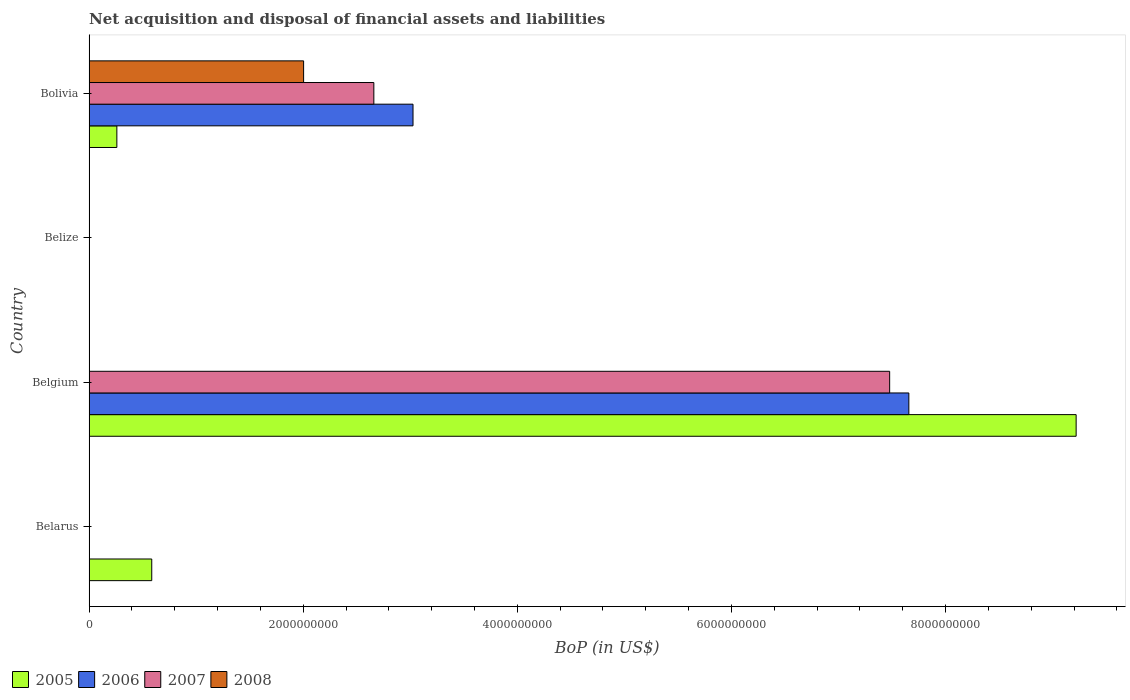How many different coloured bars are there?
Provide a succinct answer. 4. Are the number of bars per tick equal to the number of legend labels?
Ensure brevity in your answer.  No. Are the number of bars on each tick of the Y-axis equal?
Provide a short and direct response. No. What is the label of the 3rd group of bars from the top?
Keep it short and to the point. Belgium. Across all countries, what is the maximum Balance of Payments in 2005?
Offer a terse response. 9.22e+09. Across all countries, what is the minimum Balance of Payments in 2005?
Your response must be concise. 0. What is the total Balance of Payments in 2005 in the graph?
Offer a very short reply. 1.01e+1. What is the difference between the Balance of Payments in 2005 in Belarus and that in Bolivia?
Your answer should be very brief. 3.26e+08. What is the difference between the Balance of Payments in 2007 in Bolivia and the Balance of Payments in 2005 in Belize?
Offer a terse response. 2.66e+09. What is the average Balance of Payments in 2007 per country?
Offer a terse response. 2.53e+09. What is the difference between the Balance of Payments in 2005 and Balance of Payments in 2007 in Belgium?
Provide a succinct answer. 1.74e+09. What is the difference between the highest and the second highest Balance of Payments in 2005?
Your response must be concise. 8.63e+09. What is the difference between the highest and the lowest Balance of Payments in 2008?
Ensure brevity in your answer.  2.00e+09. Is the sum of the Balance of Payments in 2005 in Belarus and Belgium greater than the maximum Balance of Payments in 2007 across all countries?
Keep it short and to the point. Yes. Is it the case that in every country, the sum of the Balance of Payments in 2005 and Balance of Payments in 2008 is greater than the sum of Balance of Payments in 2006 and Balance of Payments in 2007?
Offer a terse response. No. Are the values on the major ticks of X-axis written in scientific E-notation?
Make the answer very short. No. Does the graph contain grids?
Your response must be concise. No. What is the title of the graph?
Offer a terse response. Net acquisition and disposal of financial assets and liabilities. What is the label or title of the X-axis?
Your response must be concise. BoP (in US$). What is the BoP (in US$) in 2005 in Belarus?
Provide a short and direct response. 5.85e+08. What is the BoP (in US$) of 2005 in Belgium?
Give a very brief answer. 9.22e+09. What is the BoP (in US$) in 2006 in Belgium?
Give a very brief answer. 7.66e+09. What is the BoP (in US$) of 2007 in Belgium?
Your answer should be compact. 7.48e+09. What is the BoP (in US$) of 2008 in Belgium?
Give a very brief answer. 0. What is the BoP (in US$) of 2005 in Belize?
Offer a terse response. 0. What is the BoP (in US$) of 2007 in Belize?
Your answer should be compact. 0. What is the BoP (in US$) of 2005 in Bolivia?
Offer a very short reply. 2.59e+08. What is the BoP (in US$) of 2006 in Bolivia?
Your response must be concise. 3.03e+09. What is the BoP (in US$) of 2007 in Bolivia?
Provide a succinct answer. 2.66e+09. What is the BoP (in US$) in 2008 in Bolivia?
Your answer should be compact. 2.00e+09. Across all countries, what is the maximum BoP (in US$) of 2005?
Keep it short and to the point. 9.22e+09. Across all countries, what is the maximum BoP (in US$) in 2006?
Ensure brevity in your answer.  7.66e+09. Across all countries, what is the maximum BoP (in US$) of 2007?
Make the answer very short. 7.48e+09. Across all countries, what is the maximum BoP (in US$) of 2008?
Make the answer very short. 2.00e+09. Across all countries, what is the minimum BoP (in US$) in 2005?
Give a very brief answer. 0. Across all countries, what is the minimum BoP (in US$) in 2006?
Provide a short and direct response. 0. Across all countries, what is the minimum BoP (in US$) of 2007?
Your answer should be very brief. 0. Across all countries, what is the minimum BoP (in US$) in 2008?
Your answer should be compact. 0. What is the total BoP (in US$) in 2005 in the graph?
Your answer should be compact. 1.01e+1. What is the total BoP (in US$) of 2006 in the graph?
Your response must be concise. 1.07e+1. What is the total BoP (in US$) of 2007 in the graph?
Provide a short and direct response. 1.01e+1. What is the total BoP (in US$) of 2008 in the graph?
Your response must be concise. 2.00e+09. What is the difference between the BoP (in US$) in 2005 in Belarus and that in Belgium?
Provide a succinct answer. -8.63e+09. What is the difference between the BoP (in US$) in 2005 in Belarus and that in Bolivia?
Keep it short and to the point. 3.26e+08. What is the difference between the BoP (in US$) of 2005 in Belgium and that in Bolivia?
Keep it short and to the point. 8.96e+09. What is the difference between the BoP (in US$) in 2006 in Belgium and that in Bolivia?
Give a very brief answer. 4.63e+09. What is the difference between the BoP (in US$) of 2007 in Belgium and that in Bolivia?
Make the answer very short. 4.82e+09. What is the difference between the BoP (in US$) in 2005 in Belarus and the BoP (in US$) in 2006 in Belgium?
Make the answer very short. -7.07e+09. What is the difference between the BoP (in US$) in 2005 in Belarus and the BoP (in US$) in 2007 in Belgium?
Keep it short and to the point. -6.89e+09. What is the difference between the BoP (in US$) in 2005 in Belarus and the BoP (in US$) in 2006 in Bolivia?
Ensure brevity in your answer.  -2.44e+09. What is the difference between the BoP (in US$) in 2005 in Belarus and the BoP (in US$) in 2007 in Bolivia?
Offer a terse response. -2.07e+09. What is the difference between the BoP (in US$) of 2005 in Belarus and the BoP (in US$) of 2008 in Bolivia?
Provide a succinct answer. -1.42e+09. What is the difference between the BoP (in US$) in 2005 in Belgium and the BoP (in US$) in 2006 in Bolivia?
Your response must be concise. 6.19e+09. What is the difference between the BoP (in US$) of 2005 in Belgium and the BoP (in US$) of 2007 in Bolivia?
Offer a terse response. 6.56e+09. What is the difference between the BoP (in US$) of 2005 in Belgium and the BoP (in US$) of 2008 in Bolivia?
Offer a terse response. 7.22e+09. What is the difference between the BoP (in US$) in 2006 in Belgium and the BoP (in US$) in 2007 in Bolivia?
Keep it short and to the point. 5.00e+09. What is the difference between the BoP (in US$) in 2006 in Belgium and the BoP (in US$) in 2008 in Bolivia?
Provide a succinct answer. 5.65e+09. What is the difference between the BoP (in US$) in 2007 in Belgium and the BoP (in US$) in 2008 in Bolivia?
Your response must be concise. 5.47e+09. What is the average BoP (in US$) of 2005 per country?
Your answer should be very brief. 2.52e+09. What is the average BoP (in US$) of 2006 per country?
Give a very brief answer. 2.67e+09. What is the average BoP (in US$) in 2007 per country?
Your response must be concise. 2.53e+09. What is the average BoP (in US$) of 2008 per country?
Your answer should be compact. 5.01e+08. What is the difference between the BoP (in US$) of 2005 and BoP (in US$) of 2006 in Belgium?
Offer a very short reply. 1.56e+09. What is the difference between the BoP (in US$) in 2005 and BoP (in US$) in 2007 in Belgium?
Provide a short and direct response. 1.74e+09. What is the difference between the BoP (in US$) in 2006 and BoP (in US$) in 2007 in Belgium?
Give a very brief answer. 1.79e+08. What is the difference between the BoP (in US$) of 2005 and BoP (in US$) of 2006 in Bolivia?
Your answer should be compact. -2.77e+09. What is the difference between the BoP (in US$) of 2005 and BoP (in US$) of 2007 in Bolivia?
Your response must be concise. -2.40e+09. What is the difference between the BoP (in US$) in 2005 and BoP (in US$) in 2008 in Bolivia?
Provide a short and direct response. -1.74e+09. What is the difference between the BoP (in US$) of 2006 and BoP (in US$) of 2007 in Bolivia?
Give a very brief answer. 3.66e+08. What is the difference between the BoP (in US$) of 2006 and BoP (in US$) of 2008 in Bolivia?
Give a very brief answer. 1.02e+09. What is the difference between the BoP (in US$) in 2007 and BoP (in US$) in 2008 in Bolivia?
Your answer should be compact. 6.56e+08. What is the ratio of the BoP (in US$) of 2005 in Belarus to that in Belgium?
Ensure brevity in your answer.  0.06. What is the ratio of the BoP (in US$) in 2005 in Belarus to that in Bolivia?
Offer a very short reply. 2.26. What is the ratio of the BoP (in US$) in 2005 in Belgium to that in Bolivia?
Provide a succinct answer. 35.55. What is the ratio of the BoP (in US$) of 2006 in Belgium to that in Bolivia?
Offer a terse response. 2.53. What is the ratio of the BoP (in US$) in 2007 in Belgium to that in Bolivia?
Your answer should be compact. 2.81. What is the difference between the highest and the second highest BoP (in US$) of 2005?
Your answer should be compact. 8.63e+09. What is the difference between the highest and the lowest BoP (in US$) of 2005?
Provide a succinct answer. 9.22e+09. What is the difference between the highest and the lowest BoP (in US$) of 2006?
Ensure brevity in your answer.  7.66e+09. What is the difference between the highest and the lowest BoP (in US$) in 2007?
Offer a terse response. 7.48e+09. What is the difference between the highest and the lowest BoP (in US$) in 2008?
Offer a very short reply. 2.00e+09. 